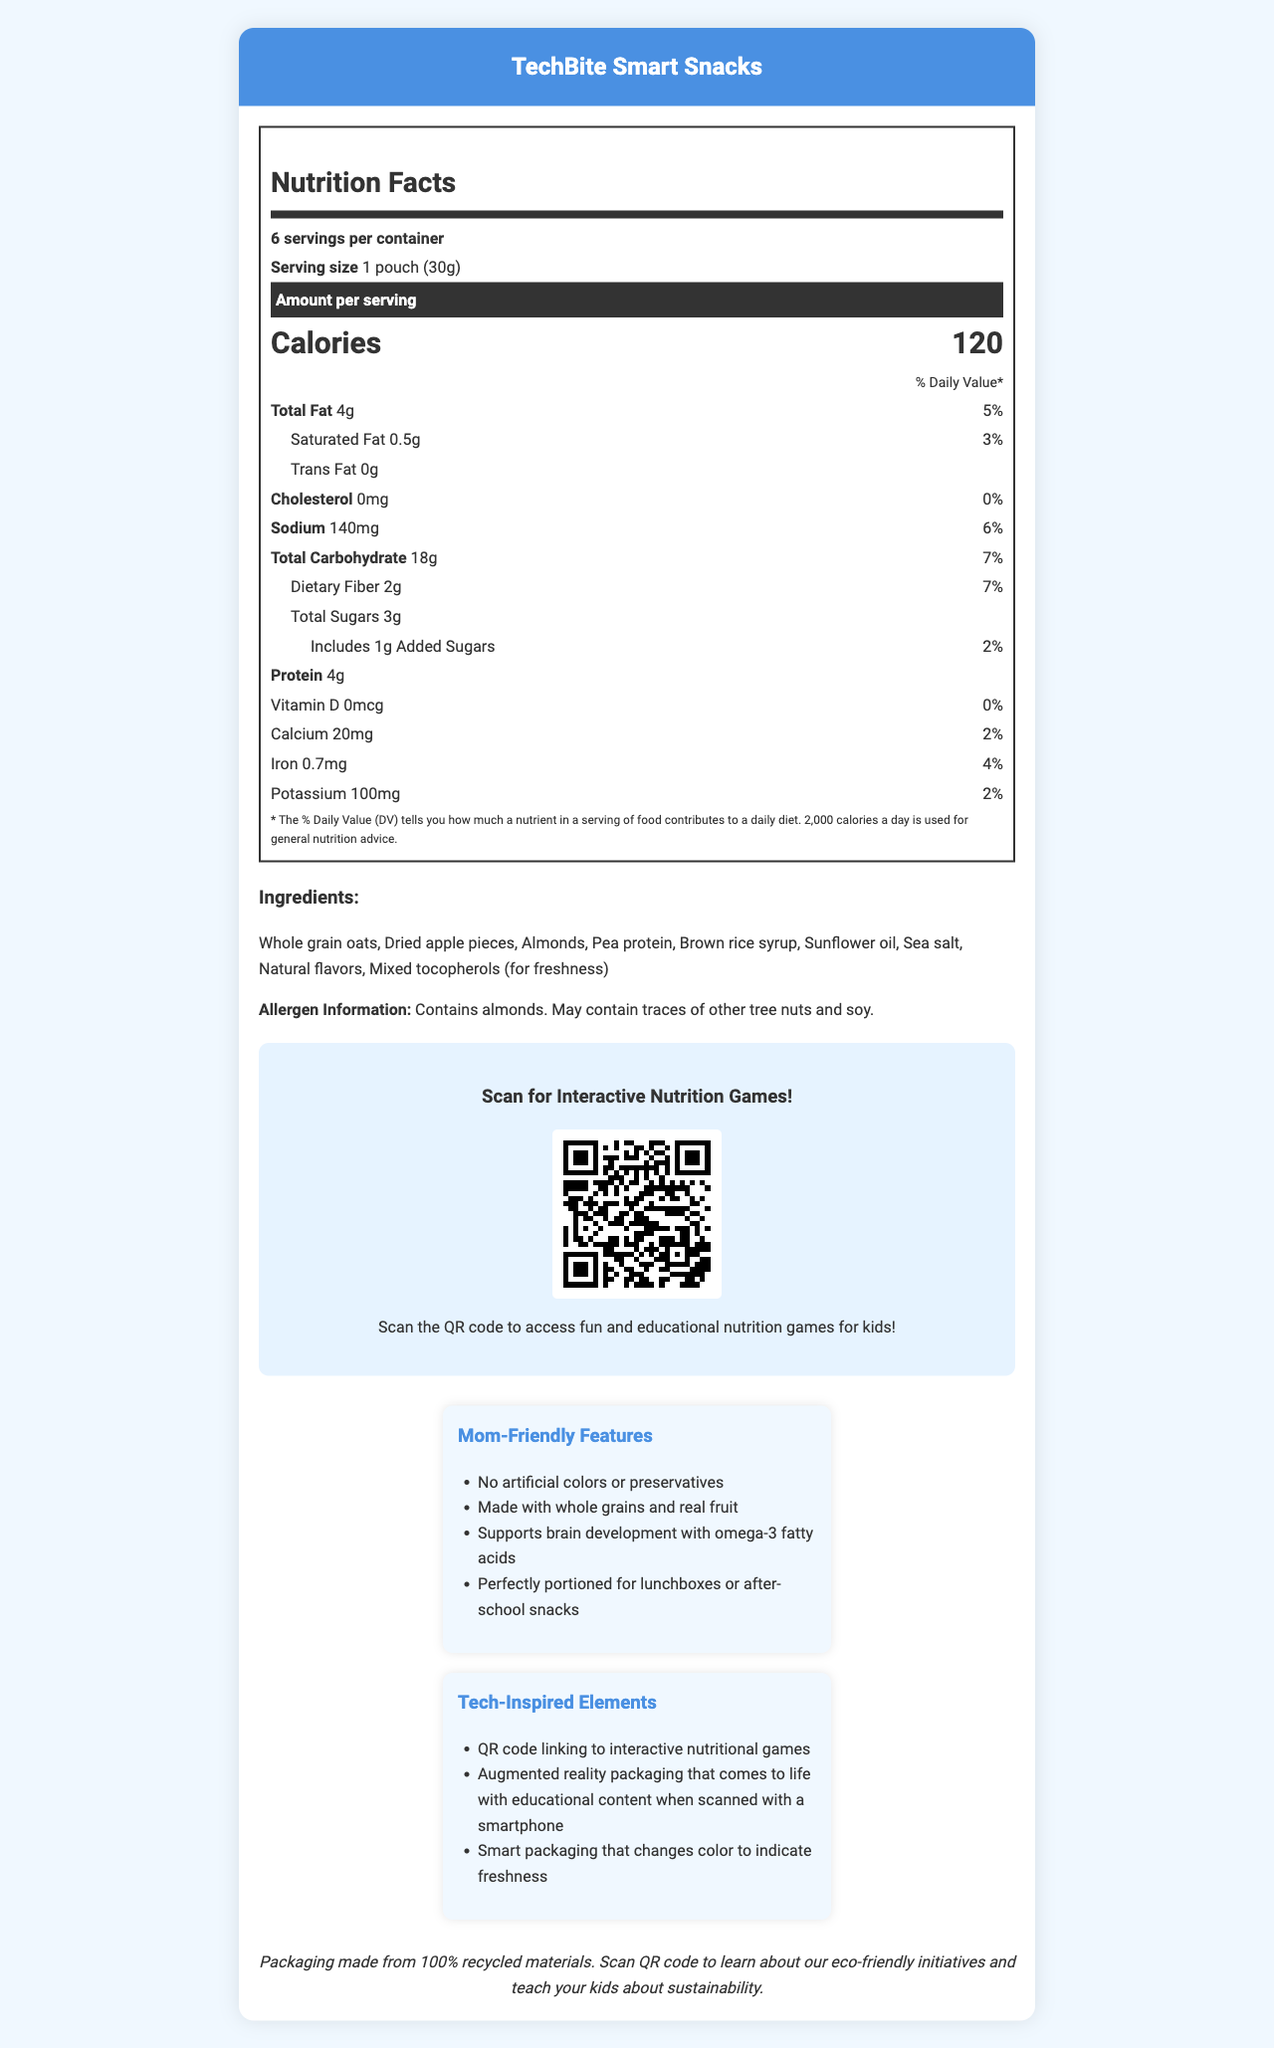what is the serving size of TechBite Smart Snacks? The document states that the serving size is listed as "1 pouch (30g)."
Answer: 1 pouch (30g) how many servings are there per container? The document states that there are 6 servings per container.
Answer: 6 what is the amount of total fat per serving? The document specifies that the total fat per serving is "4g."
Answer: 4g what ingredients are used in TechBite Smart Snacks? The document lists all the ingredients under the "Ingredients" section: "Whole grain oats, Dried apple pieces, Almonds, Pea protein, Brown rice syrup, Sunflower oil, Sea salt, Natural flavors, Mixed tocopherols (for freshness)."
Answer: Whole grain oats, Dried apple pieces, Almonds, Pea protein, Brown rice syrup, Sunflower oil, Sea salt, Natural flavors, Mixed tocopherols (for freshness) what is the website link to interactive nutrition games? The document provides a QR code link that directs to "https://techbitesnacks.com/nutrition-games."
Answer: https://techbitesnacks.com/nutrition-games what percentage of the daily value does the total carbohydrate content represent? The document lists the daily value for total carbohydrates as 7%.
Answer: 7% which of these is a game available through the QR code: a. Nutrient Hunter b. Food Detective c. Calorie Counter d. Healthy Choices The document mentions "Nutrient Hunter" as one of the interactive games available through the QR code.
Answer: a. Nutrient Hunter how much protein is in each serving? 1. 3g 2. 4g 3. 5g 4. 6g The document specifies that each serving contains 4g of protein.
Answer: 2. 4g does this product contain any tree nuts? (Yes/No) The document states in the allergen information that it contains almonds, which are tree nuts.
Answer: Yes what is the amount of added sugars per serving? The document specifies that there are 1g of added sugars per serving.
Answer: 1g describe the main idea of the document. The document provides comprehensive details about TechBite Smart Snacks, including nutritional values, ingredients, and innovative features like interactive nutritional games and sustainable packaging.
Answer: The document is a nutrition facts label for TechBite Smart Snacks, highlighting detailed nutritional information per serving, ingredients, allergen info, interactive nutritional games accessible via a QR code, mom-friendly features, tech-inspired packaging elements, and sustainability information. how does the packaging for this product support sustainability? The document mentions that the packaging is made from 100% recycled materials and includes a QR code to learn more about eco-friendly initiatives.
Answer: Packaging made from 100% recycled materials can you determine the packaging type for the product from the document? The document mentions features like augmented reality and smart packaging but does not specify the physical packaging type used.
Answer: Cannot be determined 